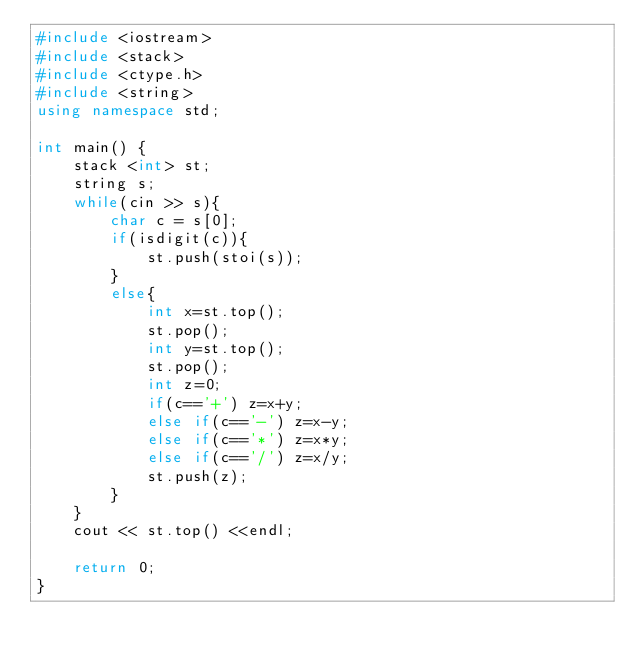<code> <loc_0><loc_0><loc_500><loc_500><_C++_>#include <iostream>
#include <stack>
#include <ctype.h>
#include <string>
using namespace std;

int main() {
	stack <int> st;
	string s;
	while(cin >> s){
		char c = s[0];
		if(isdigit(c)){
			st.push(stoi(s));
		}
		else{
			int x=st.top();
			st.pop();
			int y=st.top();
			st.pop();
			int z=0;
			if(c=='+') z=x+y;
			else if(c=='-') z=x-y;
			else if(c=='*') z=x*y;
			else if(c=='/') z=x/y;
			st.push(z);
		}
	}
	cout << st.top() <<endl;
		
	return 0;
}</code> 